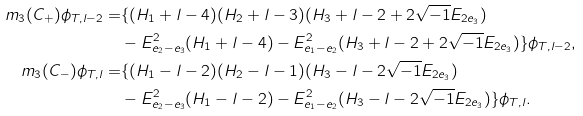<formula> <loc_0><loc_0><loc_500><loc_500>m _ { 3 } ( C _ { + } ) \phi _ { T , l - 2 } = & \{ ( H _ { 1 } + l - 4 ) ( H _ { 2 } + l - 3 ) ( H _ { 3 } + l - 2 + 2 \sqrt { - 1 } E _ { 2 e _ { 3 } } ) \\ & - E _ { e _ { 2 } - e _ { 3 } } ^ { 2 } ( H _ { 1 } + l - 4 ) - E _ { e _ { 1 } - e _ { 2 } } ^ { 2 } ( H _ { 3 } + l - 2 + 2 \sqrt { - 1 } E _ { 2 e _ { 3 } } ) \} \phi _ { T , l - 2 } , \\ m _ { 3 } ( C _ { - } ) \phi _ { T , l } = & \{ ( H _ { 1 } - l - 2 ) ( H _ { 2 } - l - 1 ) ( H _ { 3 } - l - 2 \sqrt { - 1 } E _ { 2 e _ { 3 } } ) \\ & - E _ { e _ { 2 } - e _ { 3 } } ^ { 2 } ( H _ { 1 } - l - 2 ) - E _ { e _ { 1 } - e _ { 2 } } ^ { 2 } ( H _ { 3 } - l - 2 \sqrt { - 1 } E _ { 2 e _ { 3 } } ) \} \phi _ { T , l } .</formula> 